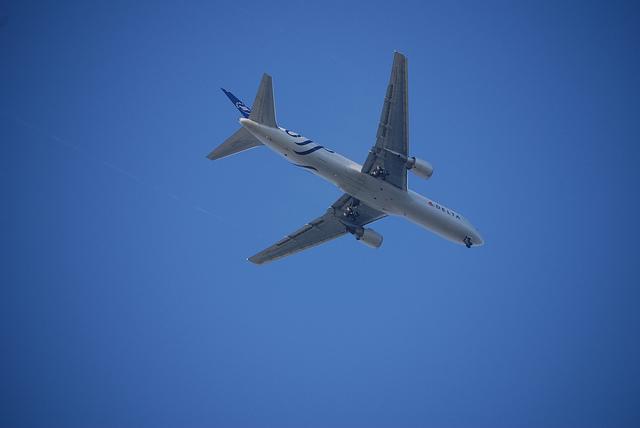How many engines on the plane?
Give a very brief answer. 2. How many white teddy bears in this image?
Give a very brief answer. 0. 